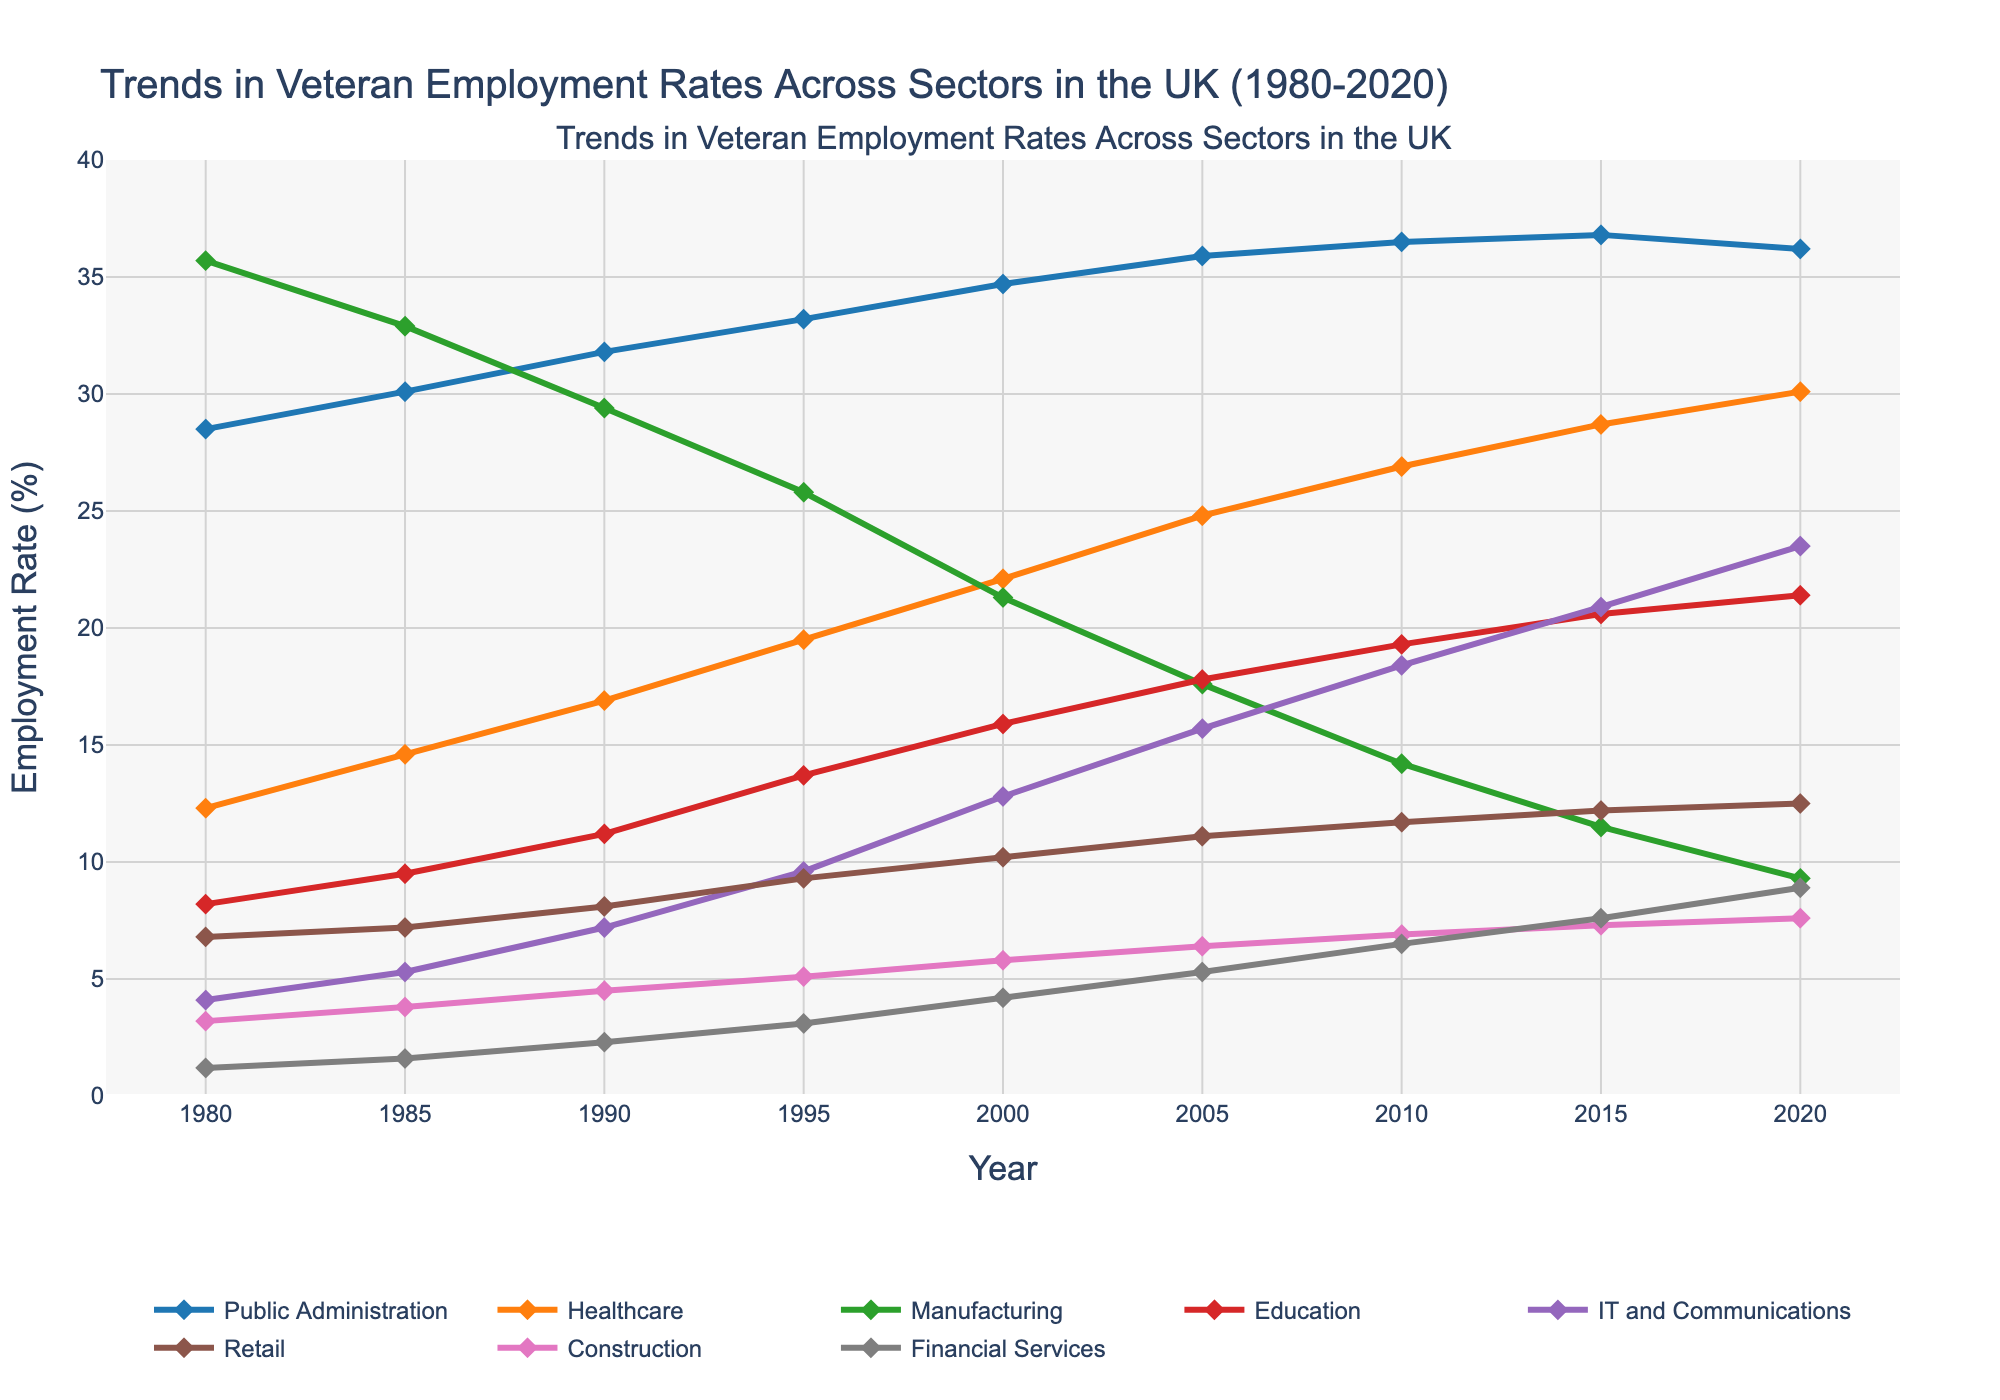What sector had the highest employment rate for veterans in 1980? In 1980, the sector with the highest employment rate can be identified by looking at the height of the lines for that year. The highest line corresponds to the Manufacturing sector.
Answer: Manufacturing How did the employment rate in the Healthcare sector change from 1980 to 2020? To find the change in employment rate, look at the Y-values for the Healthcare sector in 1980 and 2020. In 1980, it was 12.3% and in 2020 it is 30.1%. Subtract 12.3 from 30.1 to find the difference.
Answer: 17.8% Which sector experienced the most significant decline in employment rate from 1980 to 2020? The sector with the most notable decline can be identified by comparing the employment rates in 1980 and 2020 for all sectors and finding the largest decrease. Manufacturing went from 35.7% in 1980 to 9.3% in 2020.
Answer: Manufacturing In which year did the IT and Communications sector employment rate surpass that of the Manufacturing sector? Observe the points where the IT and Communications sector line crosses above the Manufacturing sector line. This happens between 2000 and 2005.
Answer: 2005 Between 1990 and 2010, which sector showed the most considerable relative increase in employment rate? Calculate the percentage increase for each sector from 1990 to 2010 by checking each sector's rate in those years and using the formula: (Value in 2010 - Value in 1990) / Value in 1990. Healthcare increased from 16.9% to 26.9%, which is the highest relative increase.
Answer: Healthcare Which sector had a relatively stable employment rate from 1980 to 2020? Look for the sector with the least change in its line trajectory over the years. Public Administration shows a stable line around 28.5% to 36.8%.
Answer: Public Administration How does the employment rate in the Construction sector compare to that in the Financial Services sector in 2020? Examine the lines for Construction and Financial Services in 2020. Construction is at 7.6% while Financial Services is at 8.9%. Compare the two values.
Answer: Financial Services is higher than Construction What's the overall trend for employment in the Education sector from 1980 to 2020? Observe the line representing the Education sector over the years. There is a steady increase from 8.2% in 1980 to 21.4% in 2020.
Answer: Increasing In which year did veteran employment in the Retail sector reach its peak? Identify the highest point of the Retail sector's line. The highest value is in 2020 at 12.5%.
Answer: 2020 